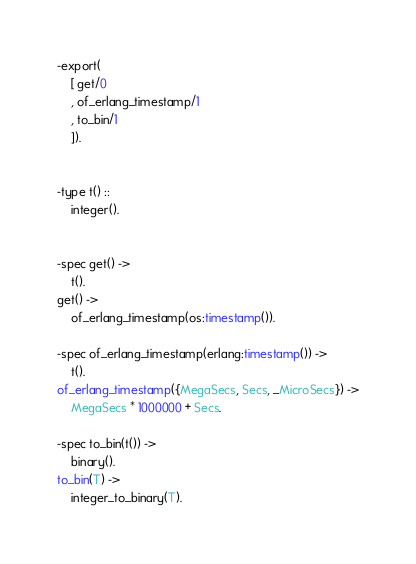<code> <loc_0><loc_0><loc_500><loc_500><_Erlang_>-export(
    [ get/0
    , of_erlang_timestamp/1
    , to_bin/1
    ]).


-type t() ::
    integer().


-spec get() ->
    t().
get() ->
    of_erlang_timestamp(os:timestamp()).

-spec of_erlang_timestamp(erlang:timestamp()) ->
    t().
of_erlang_timestamp({MegaSecs, Secs, _MicroSecs}) ->
    MegaSecs * 1000000 + Secs.

-spec to_bin(t()) ->
    binary().
to_bin(T) ->
    integer_to_binary(T).
</code> 